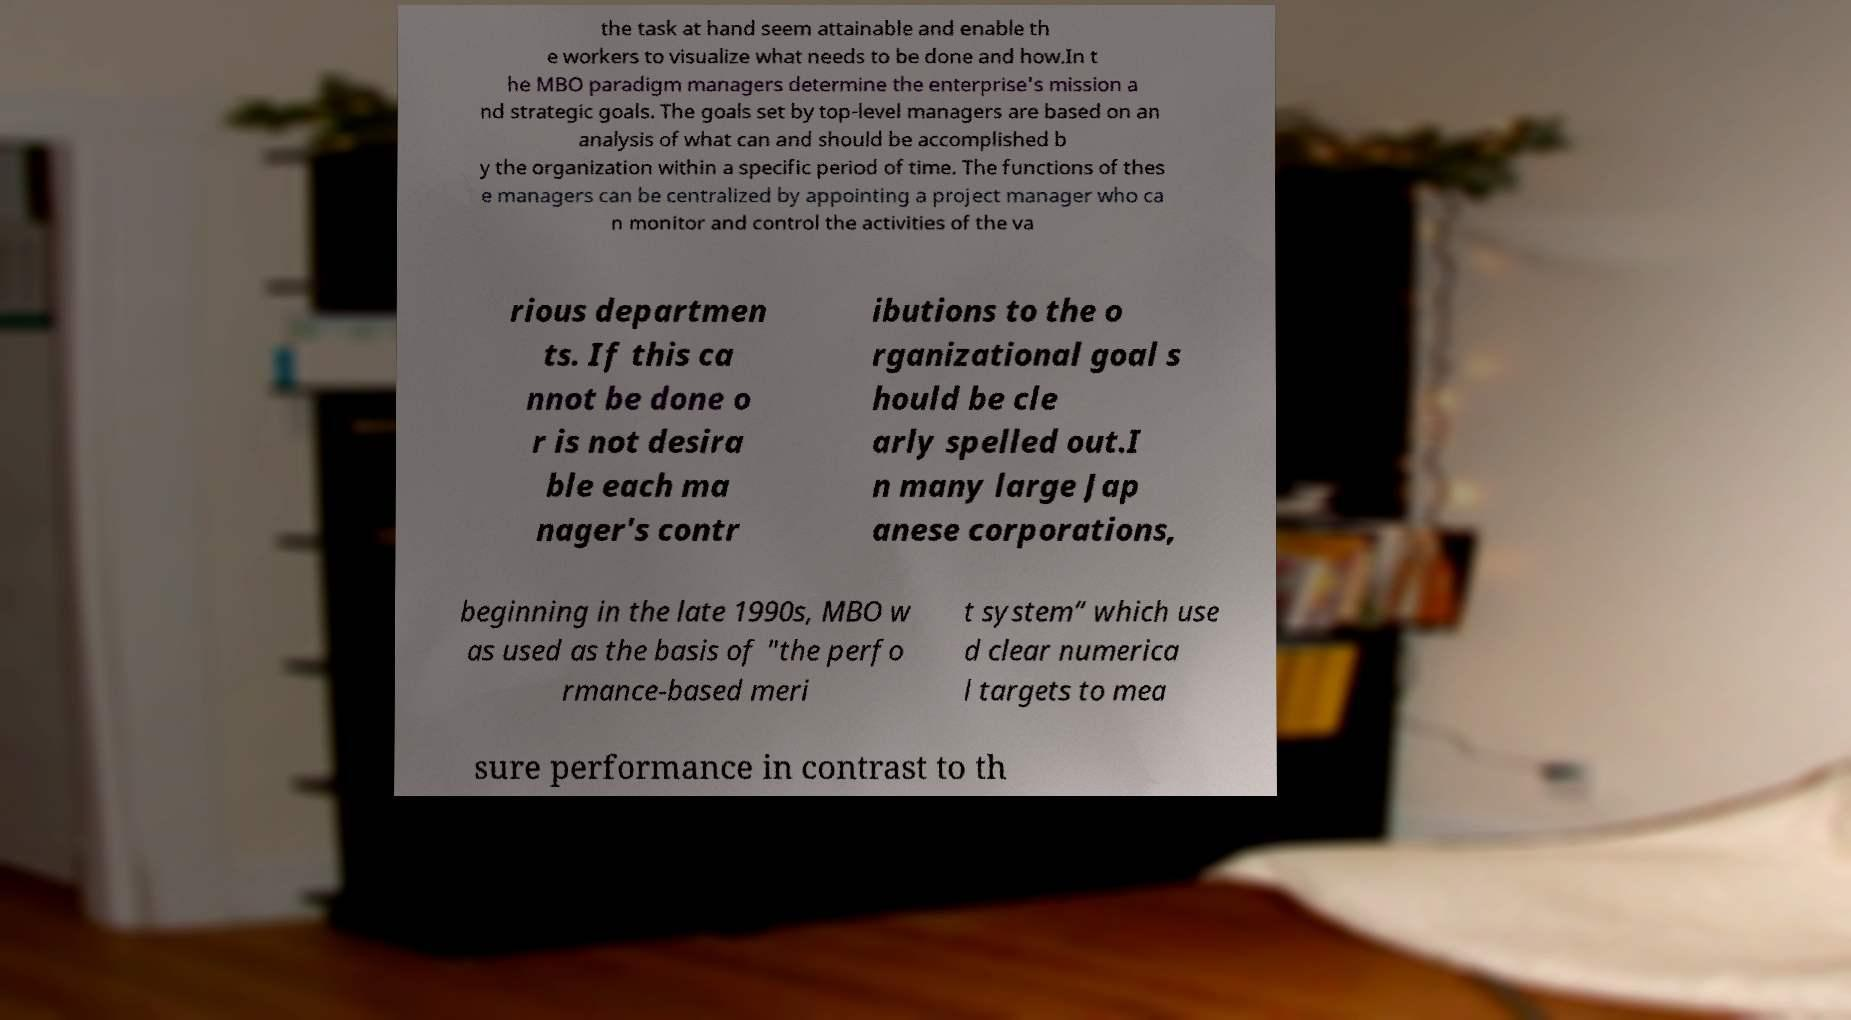Please identify and transcribe the text found in this image. the task at hand seem attainable and enable th e workers to visualize what needs to be done and how.In t he MBO paradigm managers determine the enterprise's mission a nd strategic goals. The goals set by top-level managers are based on an analysis of what can and should be accomplished b y the organization within a specific period of time. The functions of thes e managers can be centralized by appointing a project manager who ca n monitor and control the activities of the va rious departmen ts. If this ca nnot be done o r is not desira ble each ma nager's contr ibutions to the o rganizational goal s hould be cle arly spelled out.I n many large Jap anese corporations, beginning in the late 1990s, MBO w as used as the basis of "the perfo rmance-based meri t system” which use d clear numerica l targets to mea sure performance in contrast to th 